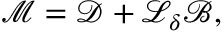<formula> <loc_0><loc_0><loc_500><loc_500>\mathcal { M } = \mathcal { D } + \mathcal { L } _ { \delta } \mathcal { B } ,</formula> 